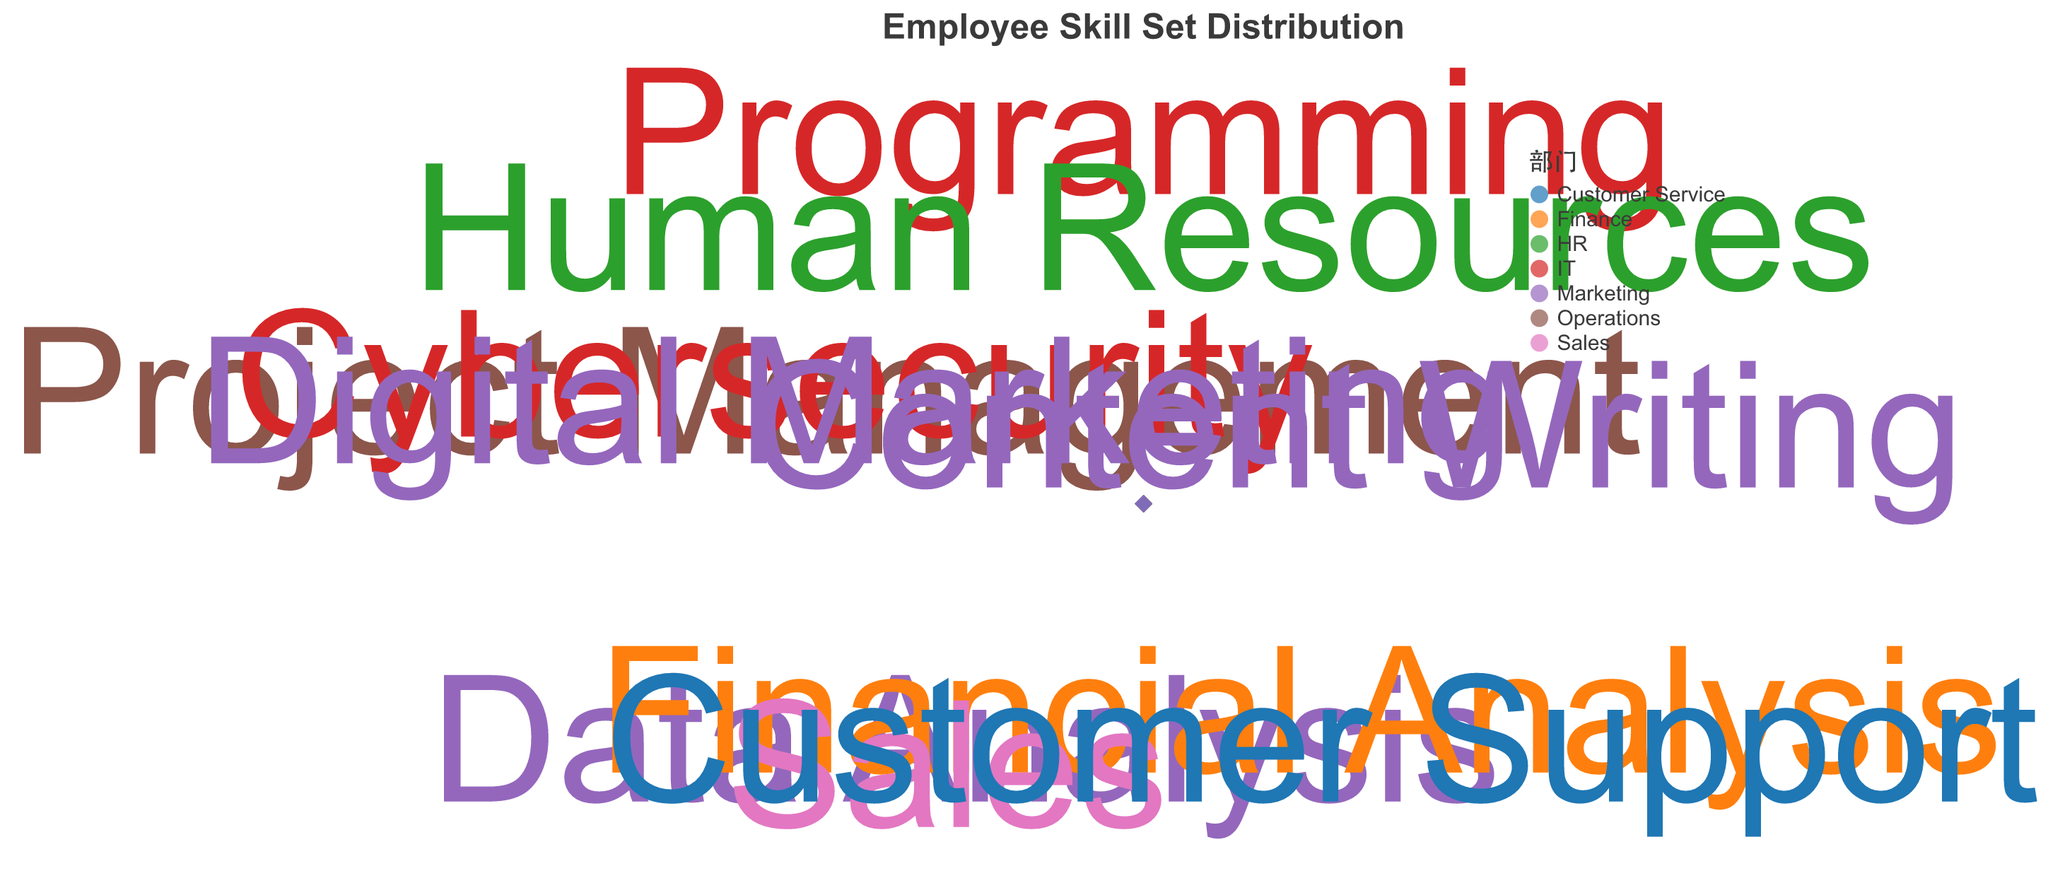Which department has the highest skill level in Programming? Identify the skill marked as Programming and note its department. The skill level of Programming is 9, which belongs to the IT department.
Answer: IT What is the average expertise level across all employees? Sum the expertise levels of all employees and divide by the number of employees. (8 + 7 + 9 + 6 + 8 + 5 + 4 + 7 + 6 + 8) = 68, average = 68/10 = 6.8
Answer: 6.8 Which skill has the highest combination of expertise level and years of experience? Look for the data point with the highest expertise level combined with the number of years of experience. Programming has an expertise level of 9 and years of experience of 6, so 9+6 = 15,  Cybersecurity has 8+x7=15+. Both highest.
Answer: Programming and Cybersecurity Do any departments have more than one skill listed? If so, which departments? Check if any departments are repeated within the data points. Marketing has Data Analysis, Content Writing, and Digital Marketing. IT has Programming and Cybersecurity.
Answer: Marketing and IT Which skill in the IT department has a higher years of experience? Compare the years of experience for IT skills like Programming and Cybersecurity. Programming has 6 years, while Cybersecurity has 7 years.
Answer: Cybersecurity How does the expertise level in Data Analysis compare to that in Financial Analysis? Compare the expertise levels of Data Analysis and Financial Analysis. Data Analysis has an expertise level of 7, and Financial Analysis has 6.
Answer: Data Analysis has a higher expertise level Based on the distribution of expertise levels and years of experience, which skill is most likely to have a leadership role within the company? A skill with a combination of high expertise level and high experience is likely to be in a leadership role. Programming has a high expertise level of 9 and relatively high experience of 6.
Answer: Programming What's the difference between the experience years in Sales and Human Resources? Subtract the years of experience in Human Resources from the years of experience in Sales. Sales has 5 years and HR has 3 years. 5 - 3 = 2
Answer: 2 What are the average expertise level and years of experience in the Marketing department? Identify the skills in Marketing and calculate the average of their expertise levels and years of experience. Expertise: (7 + 5 + 8) / 3 = 6.67. Experience: (4 + 2 + 4) / 3 = 3.33
Answer: 6.67 and 3.33 